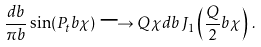Convert formula to latex. <formula><loc_0><loc_0><loc_500><loc_500>\frac { d b } { \pi b } \sin ( P _ { t } b \chi ) \longrightarrow Q \chi d b \, J _ { 1 } \left ( \frac { Q } { 2 } b \chi \right ) \, .</formula> 